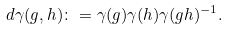Convert formula to latex. <formula><loc_0><loc_0><loc_500><loc_500>d \gamma ( g , h ) \colon = \gamma ( g ) \gamma ( h ) \gamma ( g h ) ^ { - 1 } .</formula> 